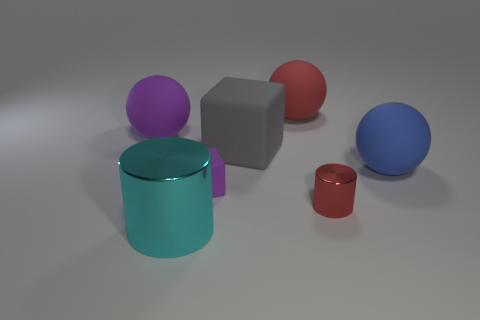What number of cylinders are either large purple things or large blue rubber things?
Give a very brief answer. 0. Is there a big purple thing that has the same shape as the cyan object?
Offer a terse response. No. How many other objects are there of the same color as the large block?
Keep it short and to the point. 0. Are there fewer big cylinders on the left side of the blue rubber thing than rubber cubes?
Make the answer very short. Yes. What number of red objects are there?
Your response must be concise. 2. What number of objects are made of the same material as the gray block?
Make the answer very short. 4. What number of objects are rubber blocks in front of the large gray cube or large yellow matte blocks?
Make the answer very short. 1. Is the number of large blue matte balls that are left of the big red matte object less than the number of large metallic cylinders right of the small red thing?
Ensure brevity in your answer.  No. There is a gray matte block; are there any purple spheres to the right of it?
Your answer should be very brief. No. How many objects are either red things behind the small purple matte cube or objects that are behind the large cyan metal object?
Make the answer very short. 6. 